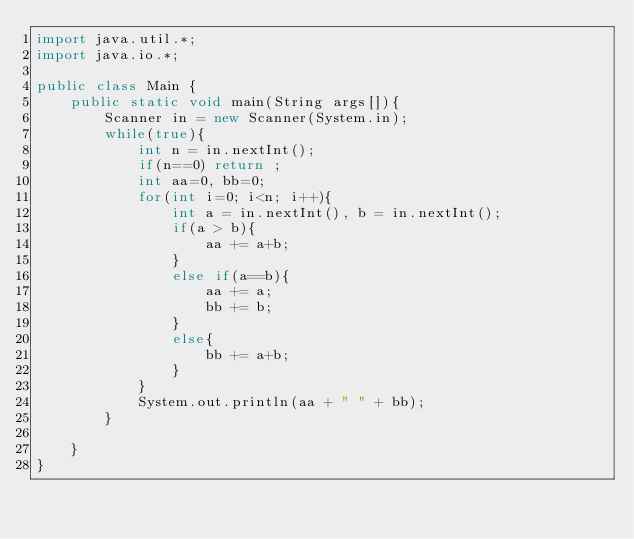<code> <loc_0><loc_0><loc_500><loc_500><_Java_>import java.util.*;
import java.io.*;

public class Main {
	public static void main(String args[]){
		Scanner in = new Scanner(System.in);
		while(true){
			int n = in.nextInt();
			if(n==0) return ;
			int aa=0, bb=0;
			for(int i=0; i<n; i++){
				int a = in.nextInt(), b = in.nextInt();
				if(a > b){
					aa += a+b;
				}
				else if(a==b){
					aa += a;
					bb += b;
				}
				else{
					bb += a+b;
				}
			}
			System.out.println(aa + " " + bb);
		}
		
	}
}</code> 